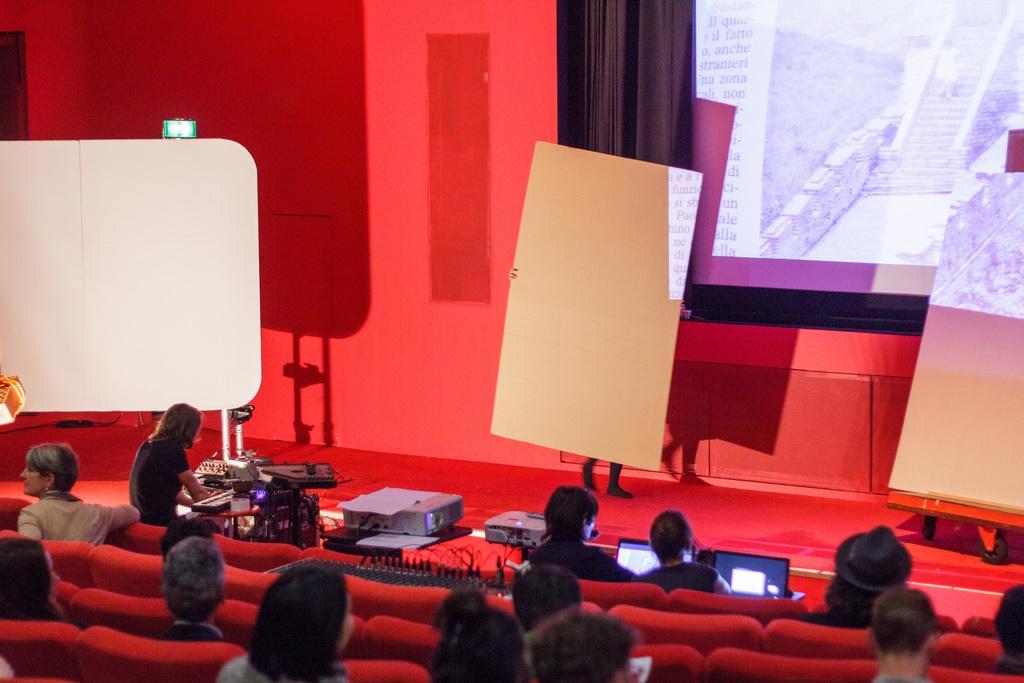How would you summarize this image in a sentence or two? In this image I can see few people are sitting on the red color seats. I can see a systems,projector and few objects on the table. In front I can see a person is holding boards and I can see a white board and large screen. 